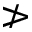Convert formula to latex. <formula><loc_0><loc_0><loc_500><loc_500>\ngtr</formula> 